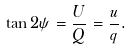<formula> <loc_0><loc_0><loc_500><loc_500>\tan 2 \psi = \frac { U } { Q } = \frac { u } { q } .</formula> 